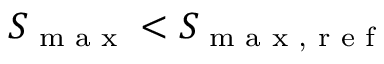<formula> <loc_0><loc_0><loc_500><loc_500>S _ { \max } < S _ { \max , r e f }</formula> 